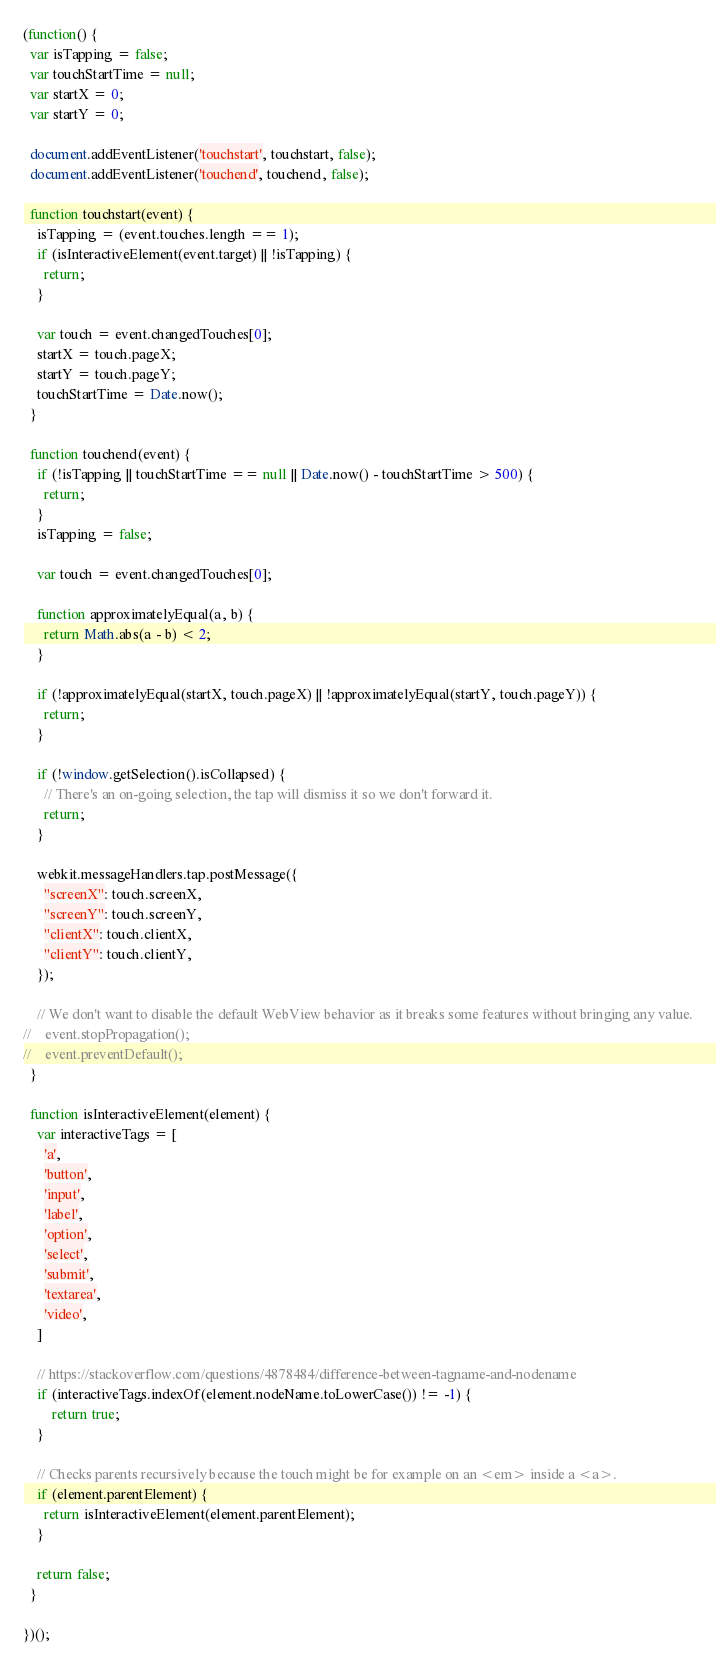<code> <loc_0><loc_0><loc_500><loc_500><_JavaScript_>(function() {
  var isTapping = false;
  var touchStartTime = null;
  var startX = 0;
  var startY = 0;

  document.addEventListener('touchstart', touchstart, false);
  document.addEventListener('touchend', touchend, false);

  function touchstart(event) {
    isTapping = (event.touches.length == 1);
    if (isInteractiveElement(event.target) || !isTapping) {
      return;
    }

    var touch = event.changedTouches[0];
    startX = touch.pageX;
    startY = touch.pageY;
    touchStartTime = Date.now();
  }

  function touchend(event) {
    if (!isTapping || touchStartTime == null || Date.now() - touchStartTime > 500) {
      return;
    }
    isTapping = false;

    var touch = event.changedTouches[0];

    function approximatelyEqual(a, b) {
      return Math.abs(a - b) < 2;
    }

    if (!approximatelyEqual(startX, touch.pageX) || !approximatelyEqual(startY, touch.pageY)) {
      return;
    }
 
    if (!window.getSelection().isCollapsed) {
      // There's an on-going selection, the tap will dismiss it so we don't forward it.
      return;
    }

    webkit.messageHandlers.tap.postMessage({
      "screenX": touch.screenX,
      "screenY": touch.screenY,
      "clientX": touch.clientX,
      "clientY": touch.clientY,
    });

    // We don't want to disable the default WebView behavior as it breaks some features without bringing any value.
//    event.stopPropagation();
//    event.preventDefault();
  }

  function isInteractiveElement(element) {
    var interactiveTags = [
      'a',
      'button',
      'input',
      'label',
      'option',
      'select',
      'submit',
      'textarea',
      'video',
    ]

    // https://stackoverflow.com/questions/4878484/difference-between-tagname-and-nodename
    if (interactiveTags.indexOf(element.nodeName.toLowerCase()) != -1) {
        return true;
    }

    // Checks parents recursively because the touch might be for example on an <em> inside a <a>.
    if (element.parentElement) {
      return isInteractiveElement(element.parentElement);
    }
    
    return false;
  }

})();
</code> 